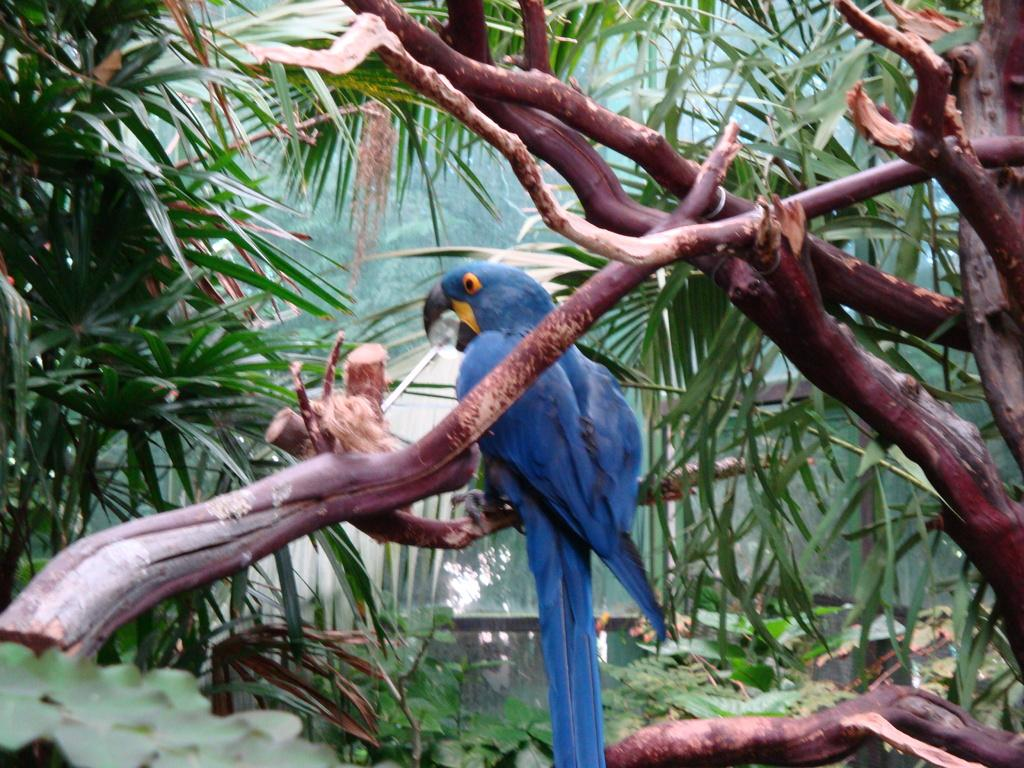What is the possible location of the image? The image might be taken from a forest. What can be seen in the middle of the image? There is a bird in the middle of the image. What is the bird standing on? The bird is standing on a tree stem. What type of vegetation is visible in the background of the image? There are trees visible in the background of the image. What type of powder can be seen covering the bird in the image? There is no powder visible on the bird in the image; it is standing on a tree stem. What type of game is being played in the background of the image? There is no game visible in the image; it features a bird standing on a tree stem in a forest setting. 